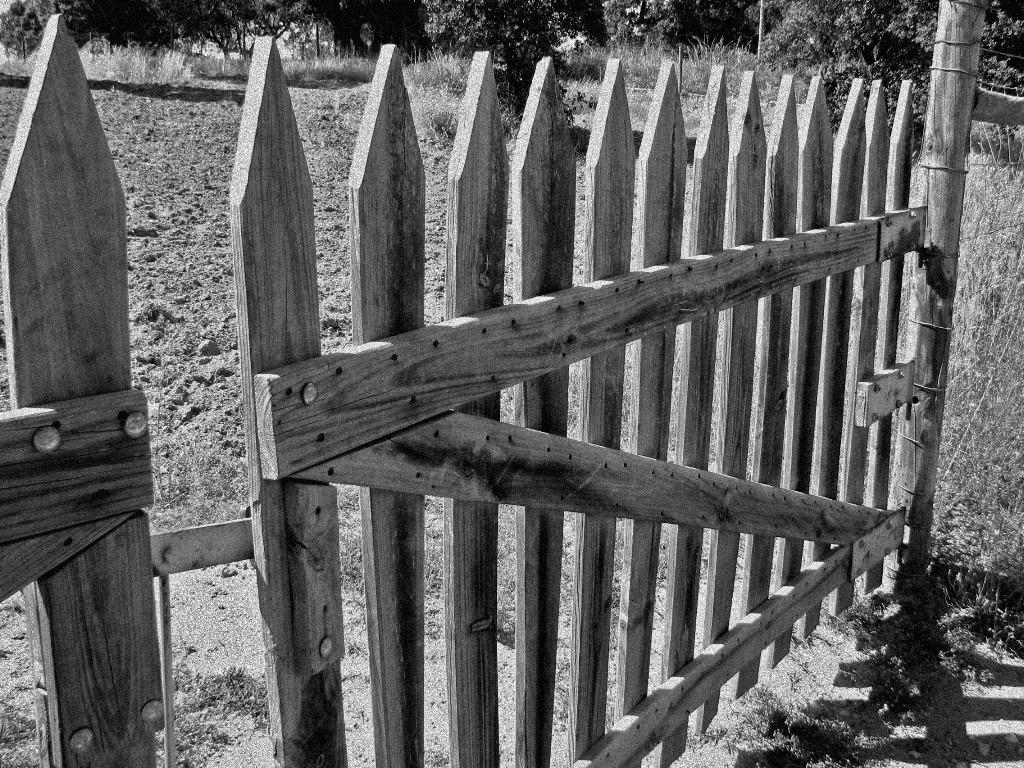What type of barrier is present in the image? There is a wooden fence in the image. What type of vegetation can be seen in the image? There is grass visible in the image. What other natural elements are present in the image? There are trees in the image. What decision does the coast make in the image? There is no coast present in the image, so it is not possible to determine any decisions made by a coast. 